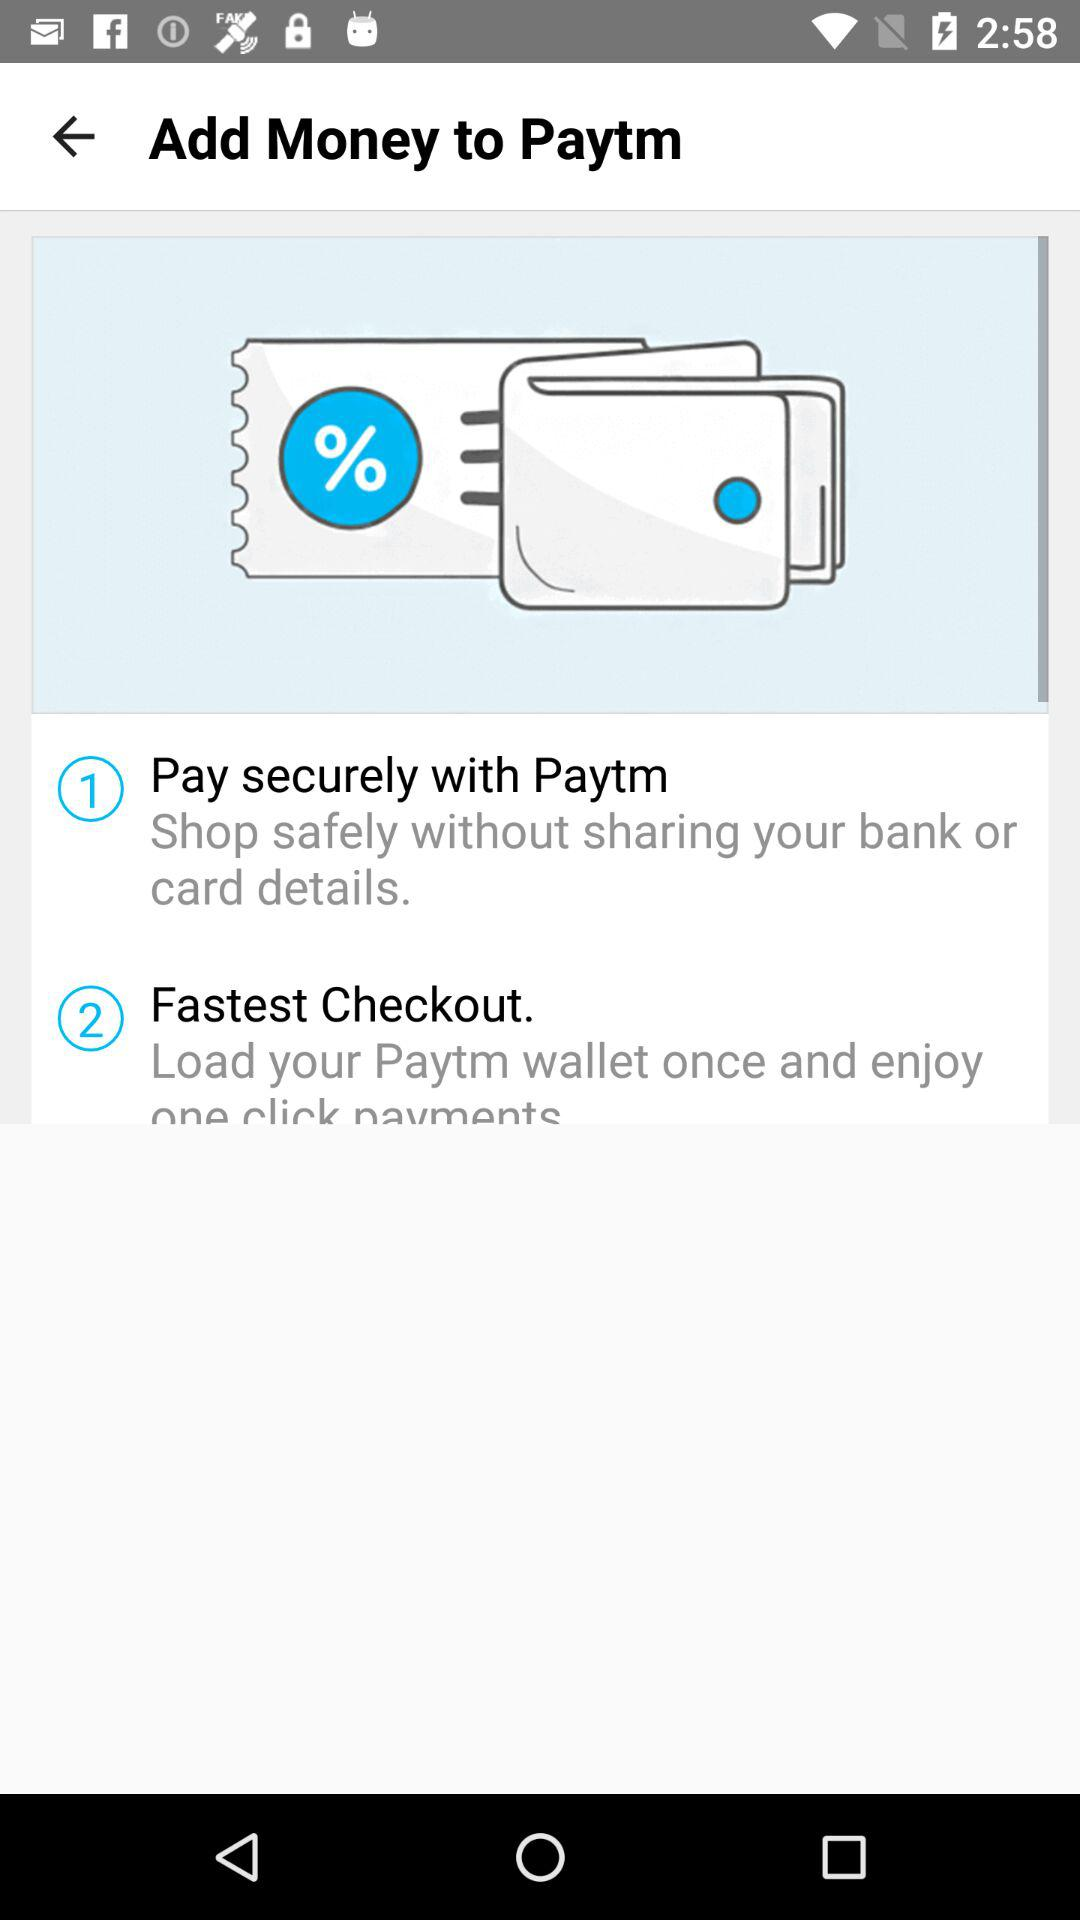How much money can be added?
When the provided information is insufficient, respond with <no answer>. <no answer> 